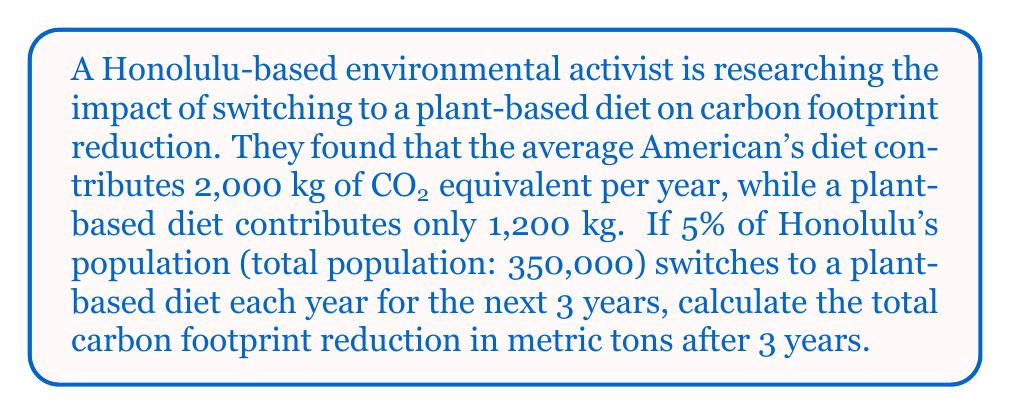Teach me how to tackle this problem. Let's approach this problem step-by-step:

1. Calculate the number of people switching to a plant-based diet each year:
   $350,000 \times 0.05 = 17,500$ people per year

2. Calculate the total number of people who have switched after 3 years:
   $17,500 \times 3 = 52,500$ people

3. Calculate the carbon footprint reduction per person:
   $2,000 \text{ kg} - 1,200 \text{ kg} = 800 \text{ kg}$ CO2 equivalent per person per year

4. Calculate the total carbon footprint reduction:
   $$\begin{align*}
   \text{Year 1: } &17,500 \times 800 = 14,000,000 \text{ kg} \\
   \text{Year 2: } &35,000 \times 800 = 28,000,000 \text{ kg} \\
   \text{Year 3: } &52,500 \times 800 = 42,000,000 \text{ kg}
   \end{align*}$$

5. Sum up the total reduction over 3 years:
   $14,000,000 + 28,000,000 + 42,000,000 = 84,000,000 \text{ kg}$

6. Convert kg to metric tons:
   $84,000,000 \text{ kg} \div 1,000 = 84,000 \text{ metric tons}$
Answer: 84,000 metric tons 